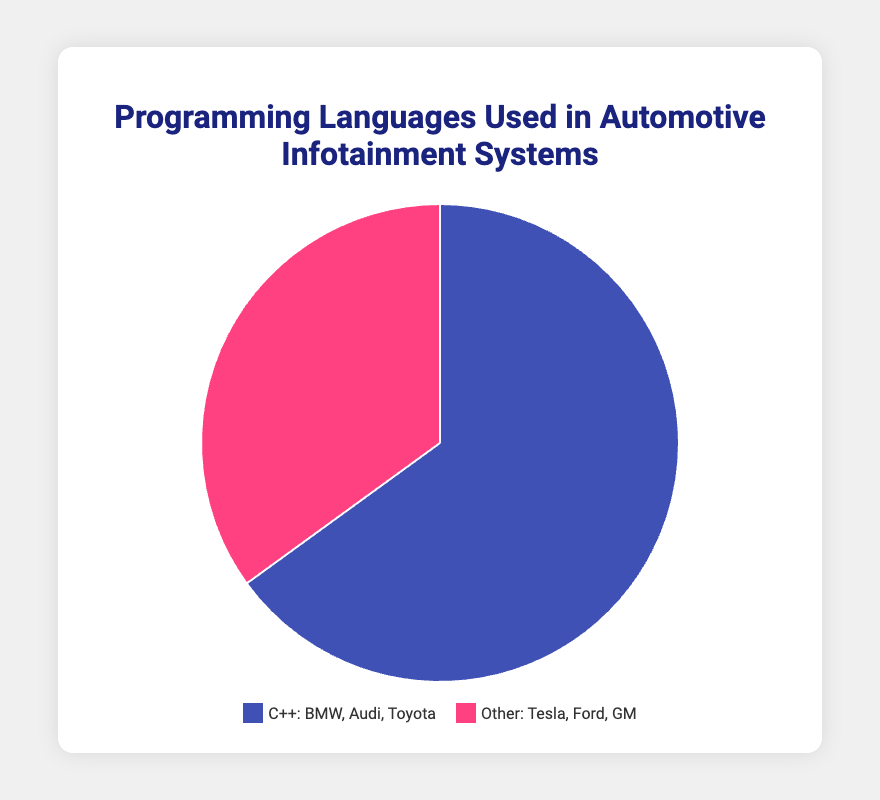What is the proportion of vehicles using C++ for their infotainment systems? The chart shows that C++ is used by 65% of the vehicles for their infotainment systems.
Answer: 65% Which programming language category has a higher proportion of use in automotive infotainment systems? The chart visually represents that C++ has a larger slice (65%) compared to 'Other' programming languages (35%).
Answer: C++ What is the difference in percentage between the use of C++ and other programming languages? The proportion of vehicles using C++ is 65% and 'Other' is 35%. The difference is calculated as 65% - 35%.
Answer: 30% How many companies are examples of using 'Other' programming languages compared to C++? The legend indicates 3 companies for 'Other' (Tesla, Ford, GM) and 3 companies for C++ (BMW, Audi, Toyota). Both categories have the same number of example companies.
Answer: Equal, 3 each If 1000 vehicles were surveyed, how many vehicles would be using 'Other' programming languages? Given 35% of the vehicles use 'Other' programming languages, multiply 1000 by 0.35 to calculate the number vehicles, 1000 * 0.35 = 350.
Answer: 350 What is the total proportion of vehicles using programming languages other than C++? The chart indicates that 35% of the vehicles use programming languages other than C++.
Answer: 35% Which color represents the vehicles using C++? The legend describes the color representing C++ is blue.
Answer: Blue What is the combined proportion of vehicles using C++ and Other languages? Adding the proportions of C++ (65%) and Other (35%) yields 65+35 = 100%. This confirms all vehicles are covered by these two categories.
Answer: 100% Which companies are examples of using C++? The legend lists BMW, Audi, and Toyota as examples of companies using C++.
Answer: BMW, Audi, Toyota 